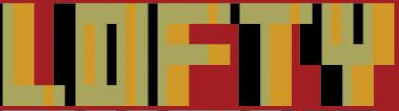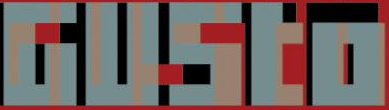Identify the words shown in these images in order, separated by a semicolon. LOFTY; GUSto 